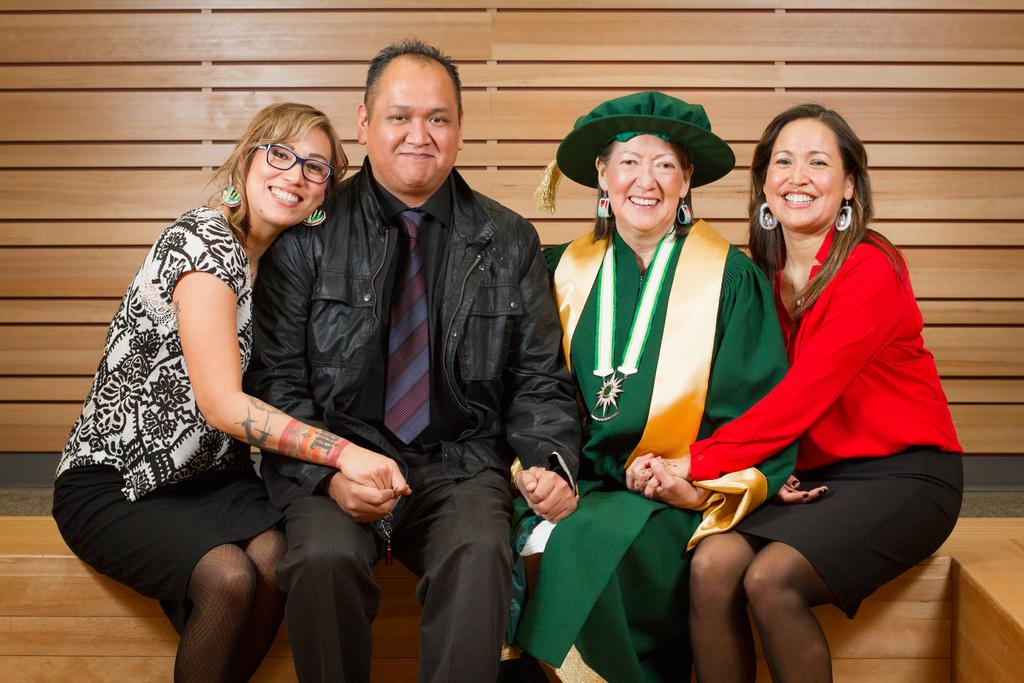How many people are present in the image? There are four people in the image: a man, a woman, and two ladies. What are the people doing in the image? The people are sitting on a wooden bench. What type of material is the bench made of? The bench is made of wood. Can you describe the background of the image? There is a wooden wall in the image. What type of powder is being used by the man in the image? There is no powder present in the image, and the man is not using any powder. 